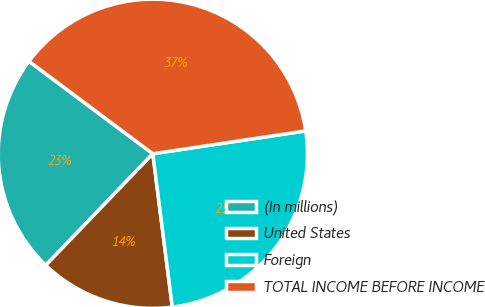Convert chart to OTSL. <chart><loc_0><loc_0><loc_500><loc_500><pie_chart><fcel>(In millions)<fcel>United States<fcel>Foreign<fcel>TOTAL INCOME BEFORE INCOME<nl><fcel>23.03%<fcel>14.19%<fcel>25.35%<fcel>37.43%<nl></chart> 